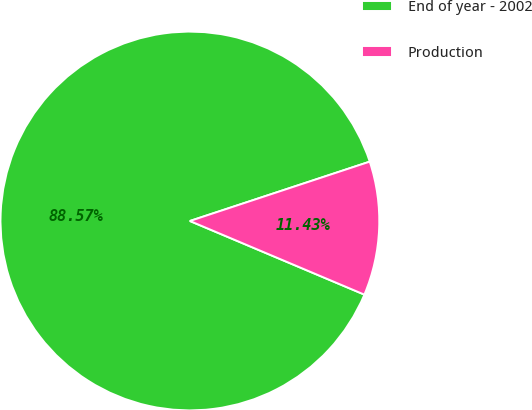Convert chart. <chart><loc_0><loc_0><loc_500><loc_500><pie_chart><fcel>End of year - 2002<fcel>Production<nl><fcel>88.57%<fcel>11.43%<nl></chart> 